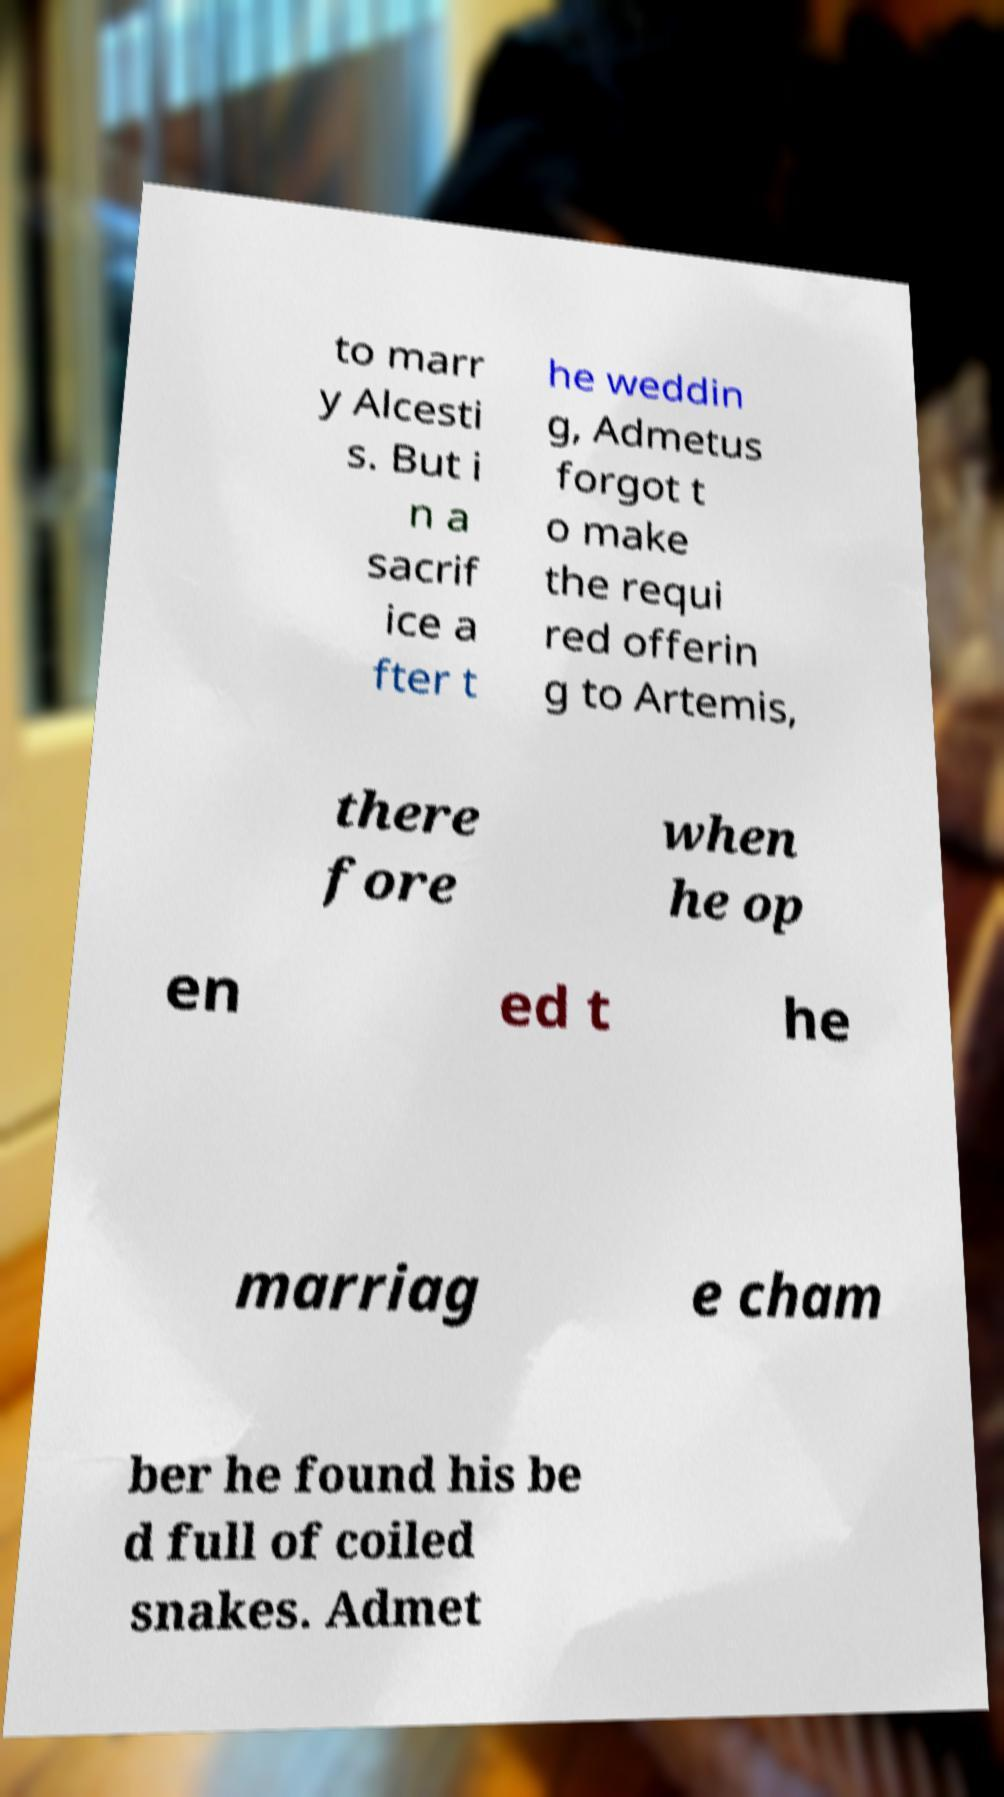There's text embedded in this image that I need extracted. Can you transcribe it verbatim? to marr y Alcesti s. But i n a sacrif ice a fter t he weddin g, Admetus forgot t o make the requi red offerin g to Artemis, there fore when he op en ed t he marriag e cham ber he found his be d full of coiled snakes. Admet 